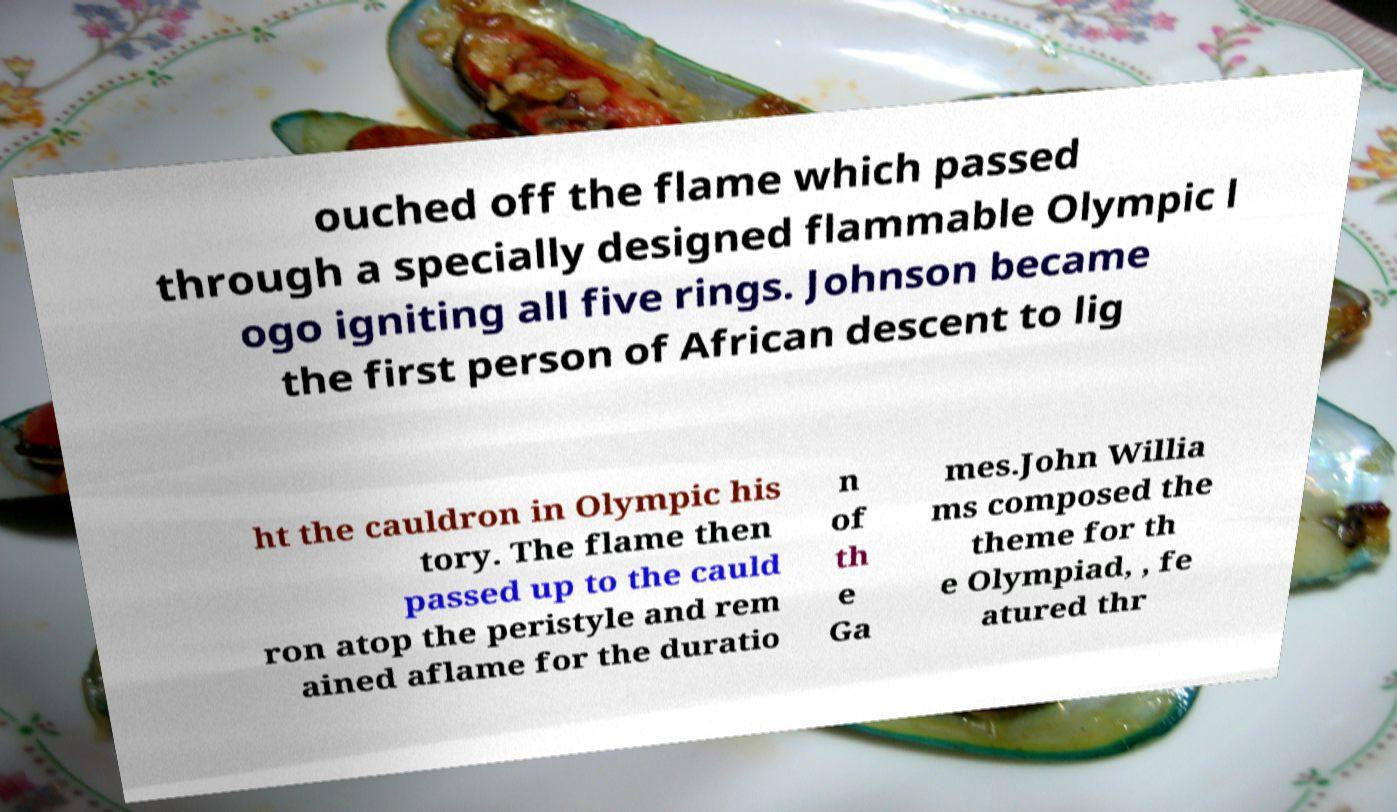I need the written content from this picture converted into text. Can you do that? ouched off the flame which passed through a specially designed flammable Olympic l ogo igniting all five rings. Johnson became the first person of African descent to lig ht the cauldron in Olympic his tory. The flame then passed up to the cauld ron atop the peristyle and rem ained aflame for the duratio n of th e Ga mes.John Willia ms composed the theme for th e Olympiad, , fe atured thr 